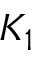<formula> <loc_0><loc_0><loc_500><loc_500>K _ { 1 }</formula> 